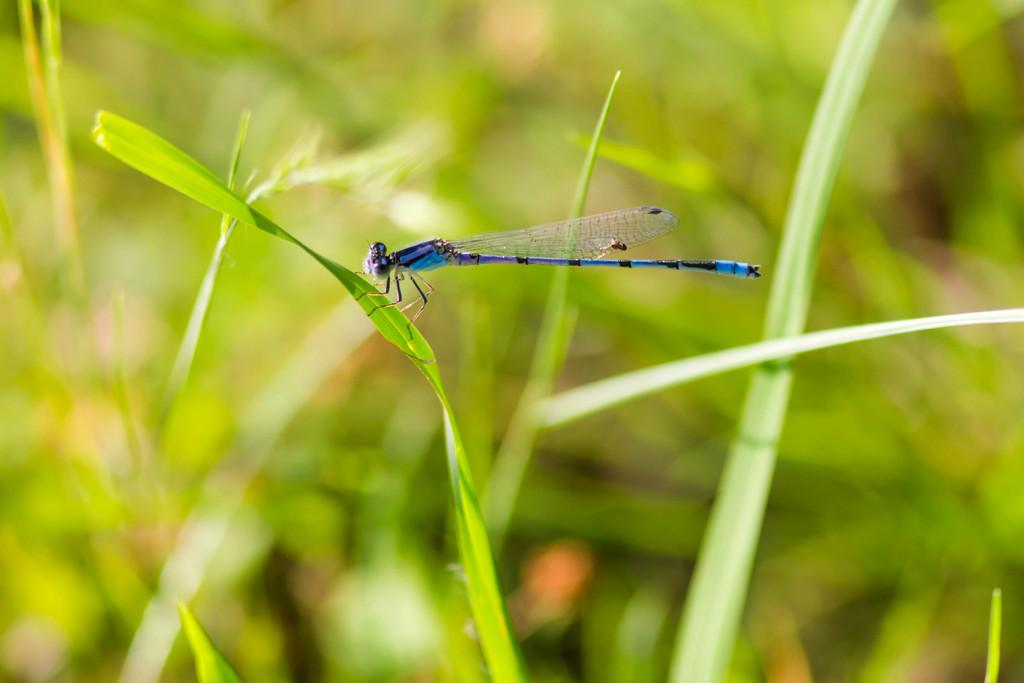What type of vegetation can be seen in the front of the image? There are leaves in the front of the image. What insect is present in the image? There is a dragonfly in the image. Can you describe the background of the image? The background of the image is blurry. How many eggs can be seen in the image? There are no eggs present in the image. What is the dragonfly learning in the image? Dragonflies do not learn in the same way as humans, so it is not possible to determine what the dragonfly might be learning in the image. 